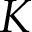Convert formula to latex. <formula><loc_0><loc_0><loc_500><loc_500>K</formula> 